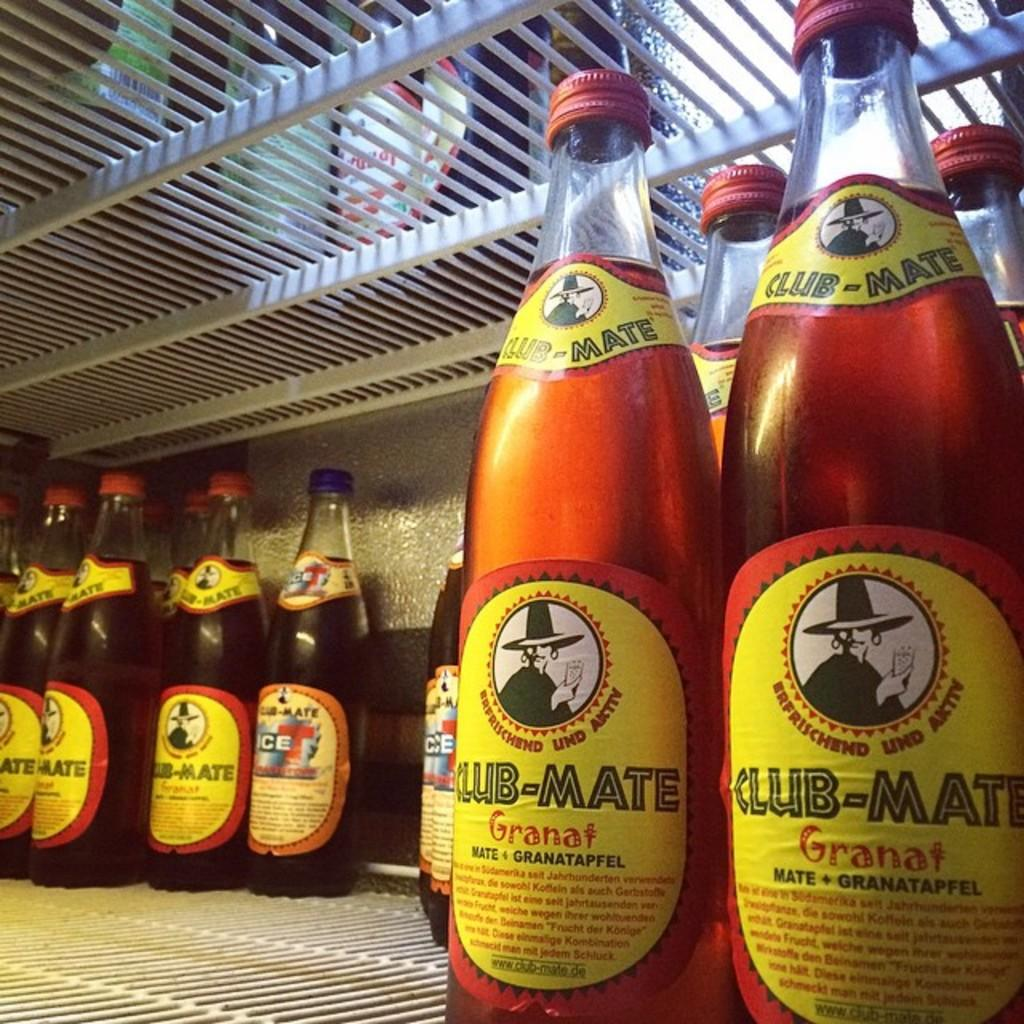Provide a one-sentence caption for the provided image. the word granat is on the bottle of liquid. 